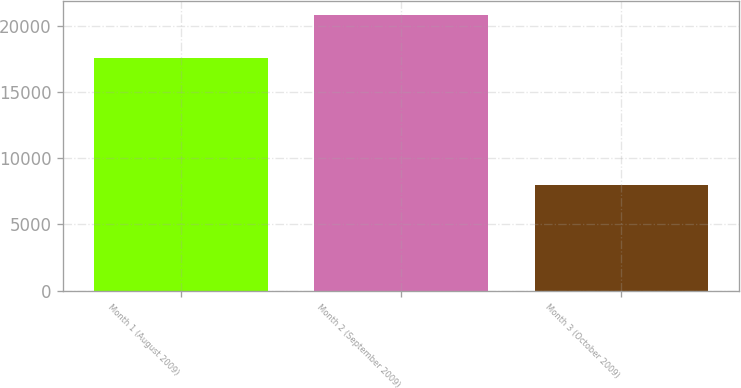Convert chart to OTSL. <chart><loc_0><loc_0><loc_500><loc_500><bar_chart><fcel>Month 1 (August 2009)<fcel>Month 2 (September 2009)<fcel>Month 3 (October 2009)<nl><fcel>17589<fcel>20889<fcel>7972<nl></chart> 